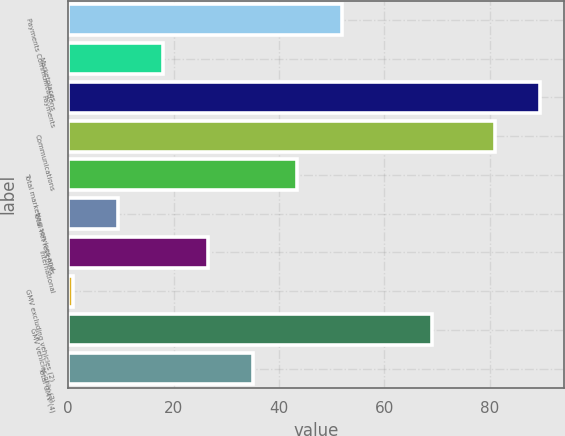Convert chart to OTSL. <chart><loc_0><loc_0><loc_500><loc_500><bar_chart><fcel>Payments Communications<fcel>Marketplaces<fcel>Payments<fcel>Communications<fcel>Total marketing services and<fcel>Total net revenues<fcel>International<fcel>GMV excluding vehicles (2)<fcel>GMV vehicles only (3)<fcel>Total GMV (4)<nl><fcel>52<fcel>18<fcel>89.5<fcel>81<fcel>43.5<fcel>9.5<fcel>26.5<fcel>1<fcel>69<fcel>35<nl></chart> 